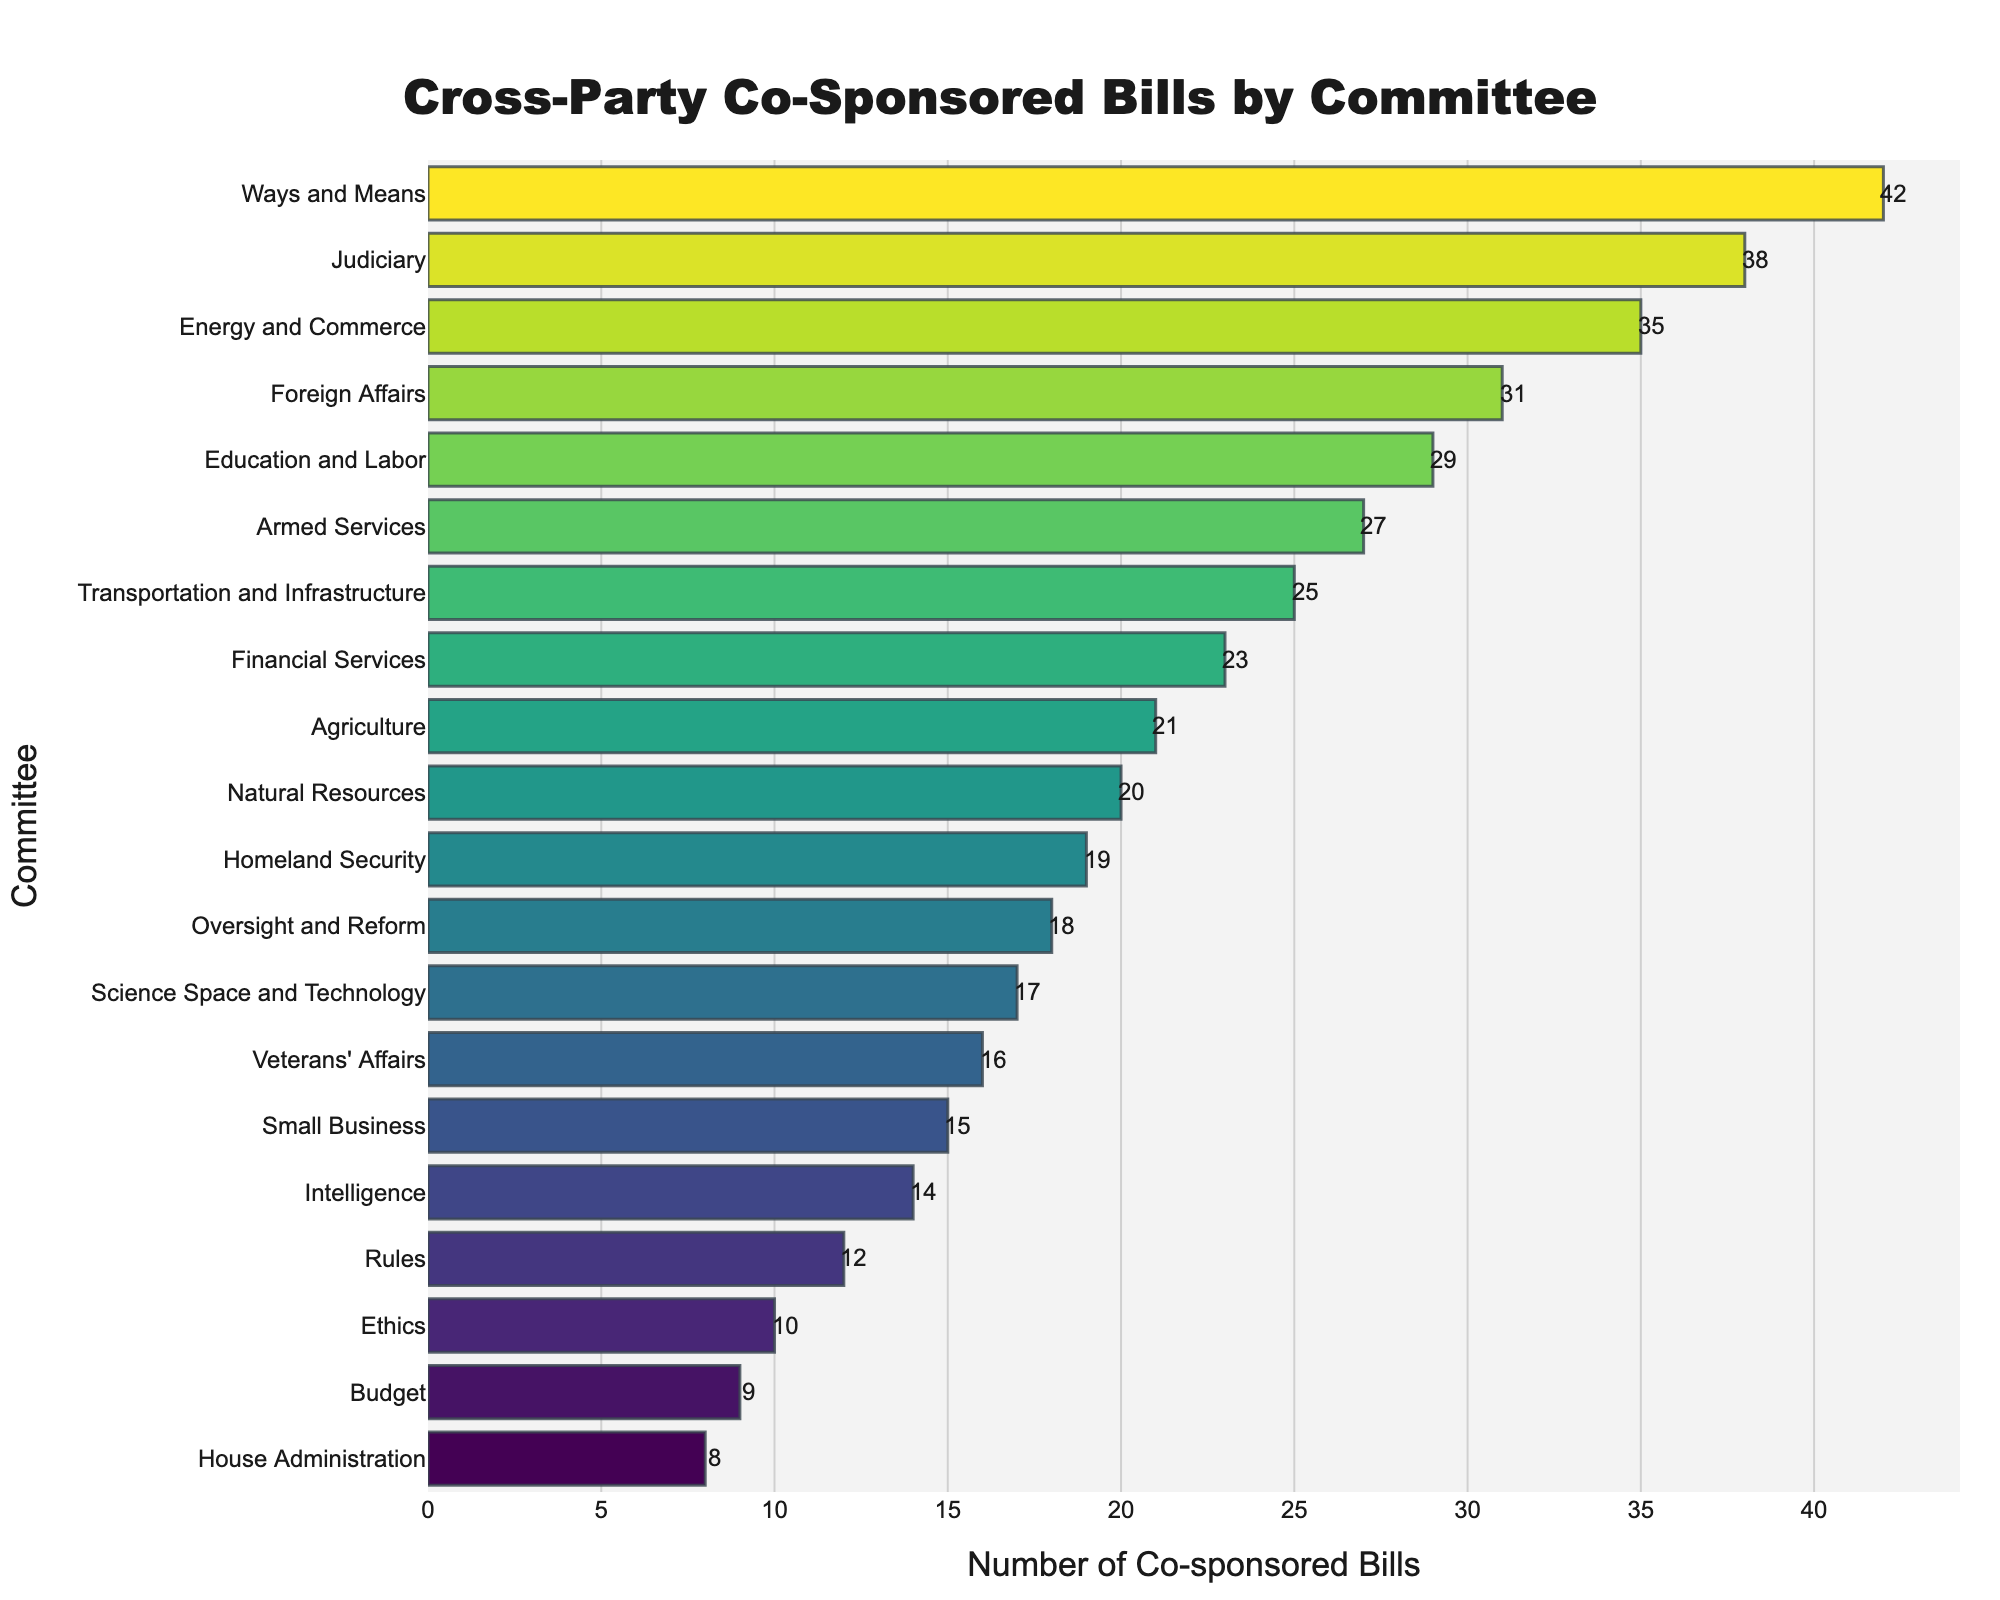Which committee has introduced the highest number of cross-party co-sponsored bills? The bar chart shows the Ways and Means Committee at the top with the tallest bar, indicating the highest number of co-sponsored bills.
Answer: Ways and Means Which three committees have introduced the least number of cross-party co-sponsored bills? The shortest bars on the graph correspond to the Ethics, Budget, and House Administration Committees.
Answer: Ethics, Budget, House Administration What is the difference in the number of cross-party co-sponsored bills between the Ways and Means Committee and the House Administration Committee? The number of bills for Ways and Means is 42 and for House Administration is 8. The difference is 42 - 8 = 34.
Answer: 34 What is the total number of cross-party co-sponsored bills introduced by the Judiciary, Energy and Commerce, and Foreign Affairs Committees combined? The numbers are: Judiciary (38), Energy and Commerce (35), and Foreign Affairs (31). Summing these gives 38 + 35 + 31 = 104.
Answer: 104 What is the average number of cross-party co-sponsored bills introduced by the Education and Labor, Armed Services, and Transportation and Infrastructure Committees? The numbers are: Education and Labor (29), Armed Services (27), and Transportation and Infrastructure (25). The sum is 29 + 27 + 25 = 81, and dividing by 3, we get 81 / 3 = 27.
Answer: 27 Which committee has introduced more cross-party co-sponsored bills, Financial Services or Agriculture, and by how many? Financial Services has 23 bills and Agriculture has 21. The difference is 23 - 21 = 2.
Answer: Financial Services, 2 What is the median number of cross-party co-sponsored bills introduced by all the committees? The data, when sorted, gives: 8, 9, 10, 12, 14, 15, 16, 17, 18, 19, 20, 21, 23, 25, 27, 29, 31, 35, 38, 42. The middle values are 19 and 20, so the median is (19 + 20) / 2 = 19.5.
Answer: 19.5 Is the number of cross-party co-sponsored bills introduced by the Rules Committee greater than that of the Ethics Committee? The Rules Committee introduced 12 bills, while the Ethics Committee introduced 10 bills. Since 12 > 10, the answer is yes.
Answer: Yes 